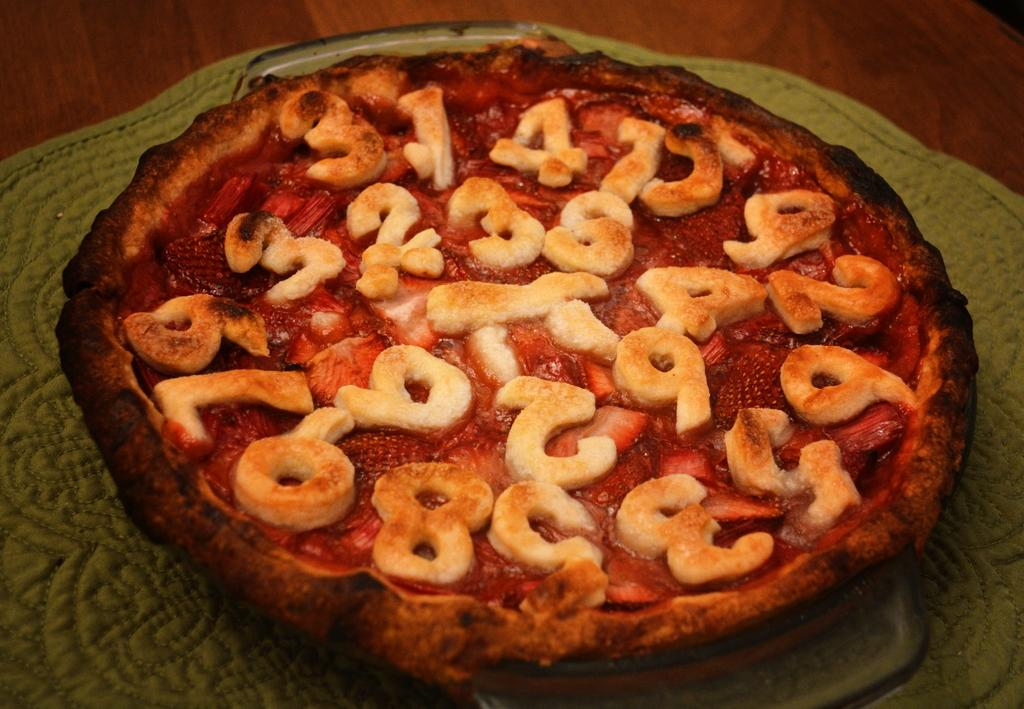What type of surface is present in the image? There is a wooden surface in the image. What is placed on the wooden surface? There is a green table mat on the wooden surface. What can be seen on the green table mat? There is food visible in the image. What type of lead can be seen on the wooden surface in the image? There is no lead present in the image; it features a wooden surface with a green table mat and food. How many legs are visible in the image? There is no reference to any legs in the image, as it only shows a wooden surface, a green table mat, and food. 